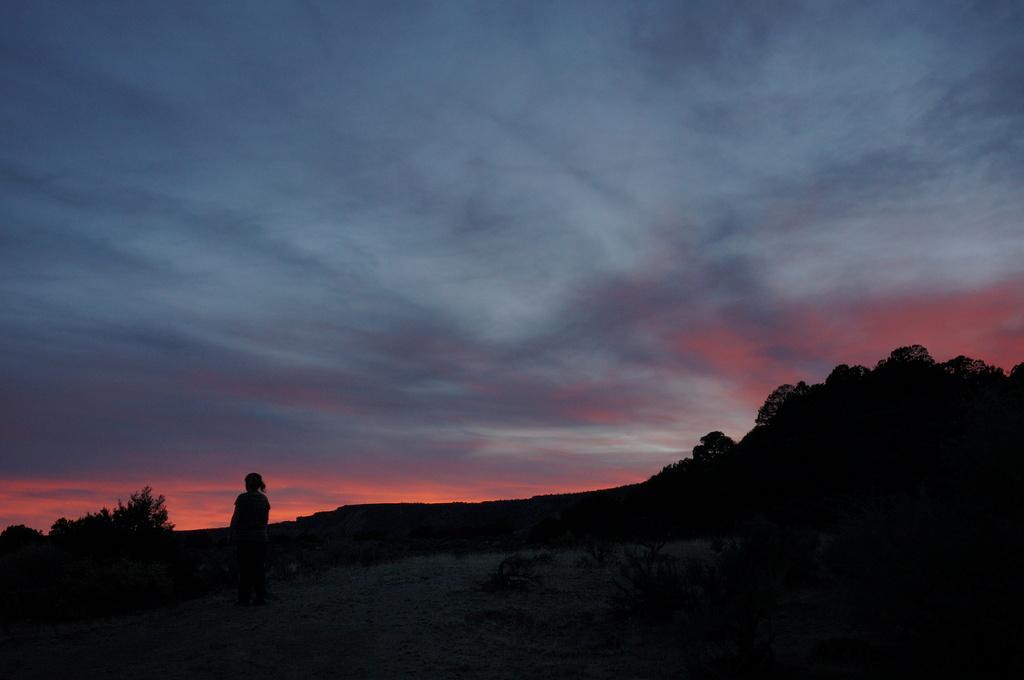Can you describe this image briefly? In this image we can see a person standing on the ground, there are some trees and also we can see the sky with clouds. 